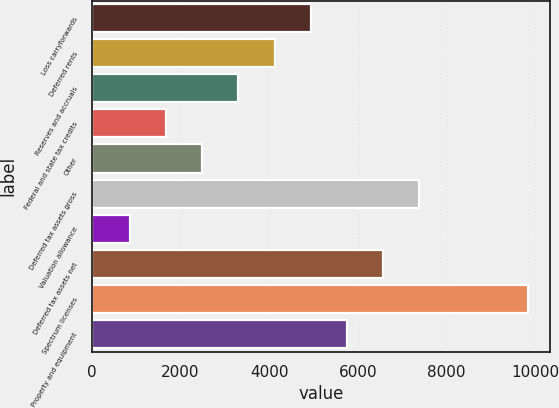<chart> <loc_0><loc_0><loc_500><loc_500><bar_chart><fcel>Loss carryforwards<fcel>Deferred rents<fcel>Reserves and accruals<fcel>Federal and state tax credits<fcel>Other<fcel>Deferred tax assets gross<fcel>Valuation allowance<fcel>Deferred tax assets net<fcel>Spectrum licenses<fcel>Property and equipment<nl><fcel>4936<fcel>4120<fcel>3304<fcel>1672<fcel>2488<fcel>7384<fcel>856<fcel>6568<fcel>9832<fcel>5752<nl></chart> 